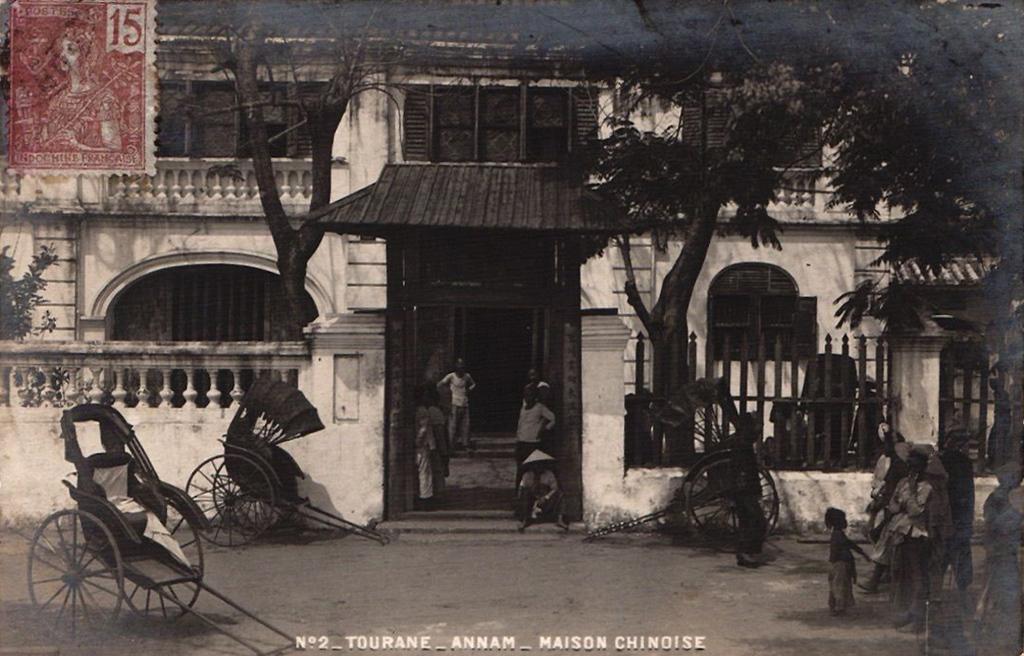Describe this image in one or two sentences. In this image few persons are standing on the land. A person wearing a hat is sitting at the entrance. Few persons are standing near the fence. There are carts before the fence. Behind the fence there are few trees and a house. Left top there is a stamp having a picture of a person on it. Bottom of image there is some text. 